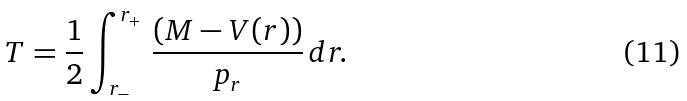<formula> <loc_0><loc_0><loc_500><loc_500>T = \frac { 1 } { 2 } \int _ { r _ { - } } ^ { r _ { + } } \, \frac { ( M - V ( r ) ) } { p _ { r } } \, d r .</formula> 